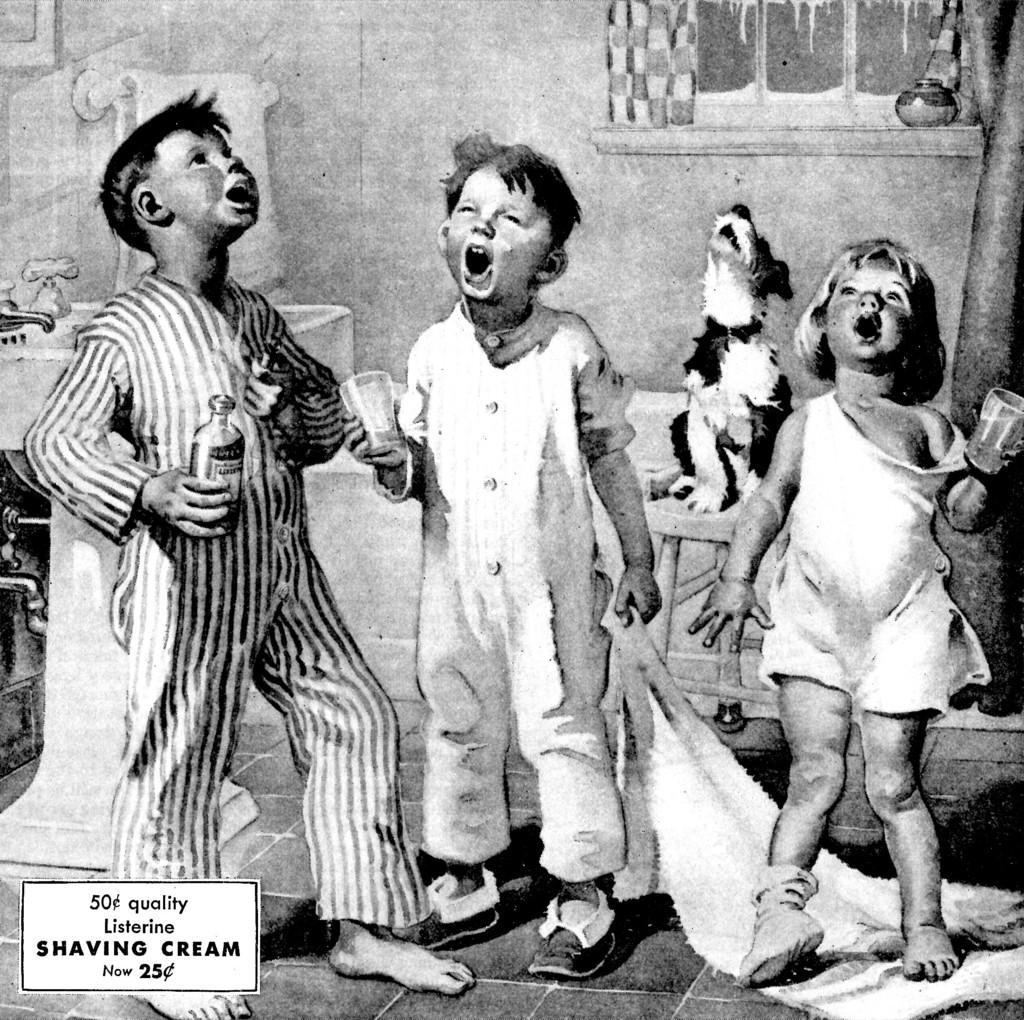In one or two sentences, can you explain what this image depicts? In this image we can see three kids, one of them is holding a bottle, two kids are holding glasses, there is a dog on the stool, there is a sink, taps, there is a towel on the road, there is a window, also we can see some other objects, one boy is holding a towel, also we can see the text on the image. 